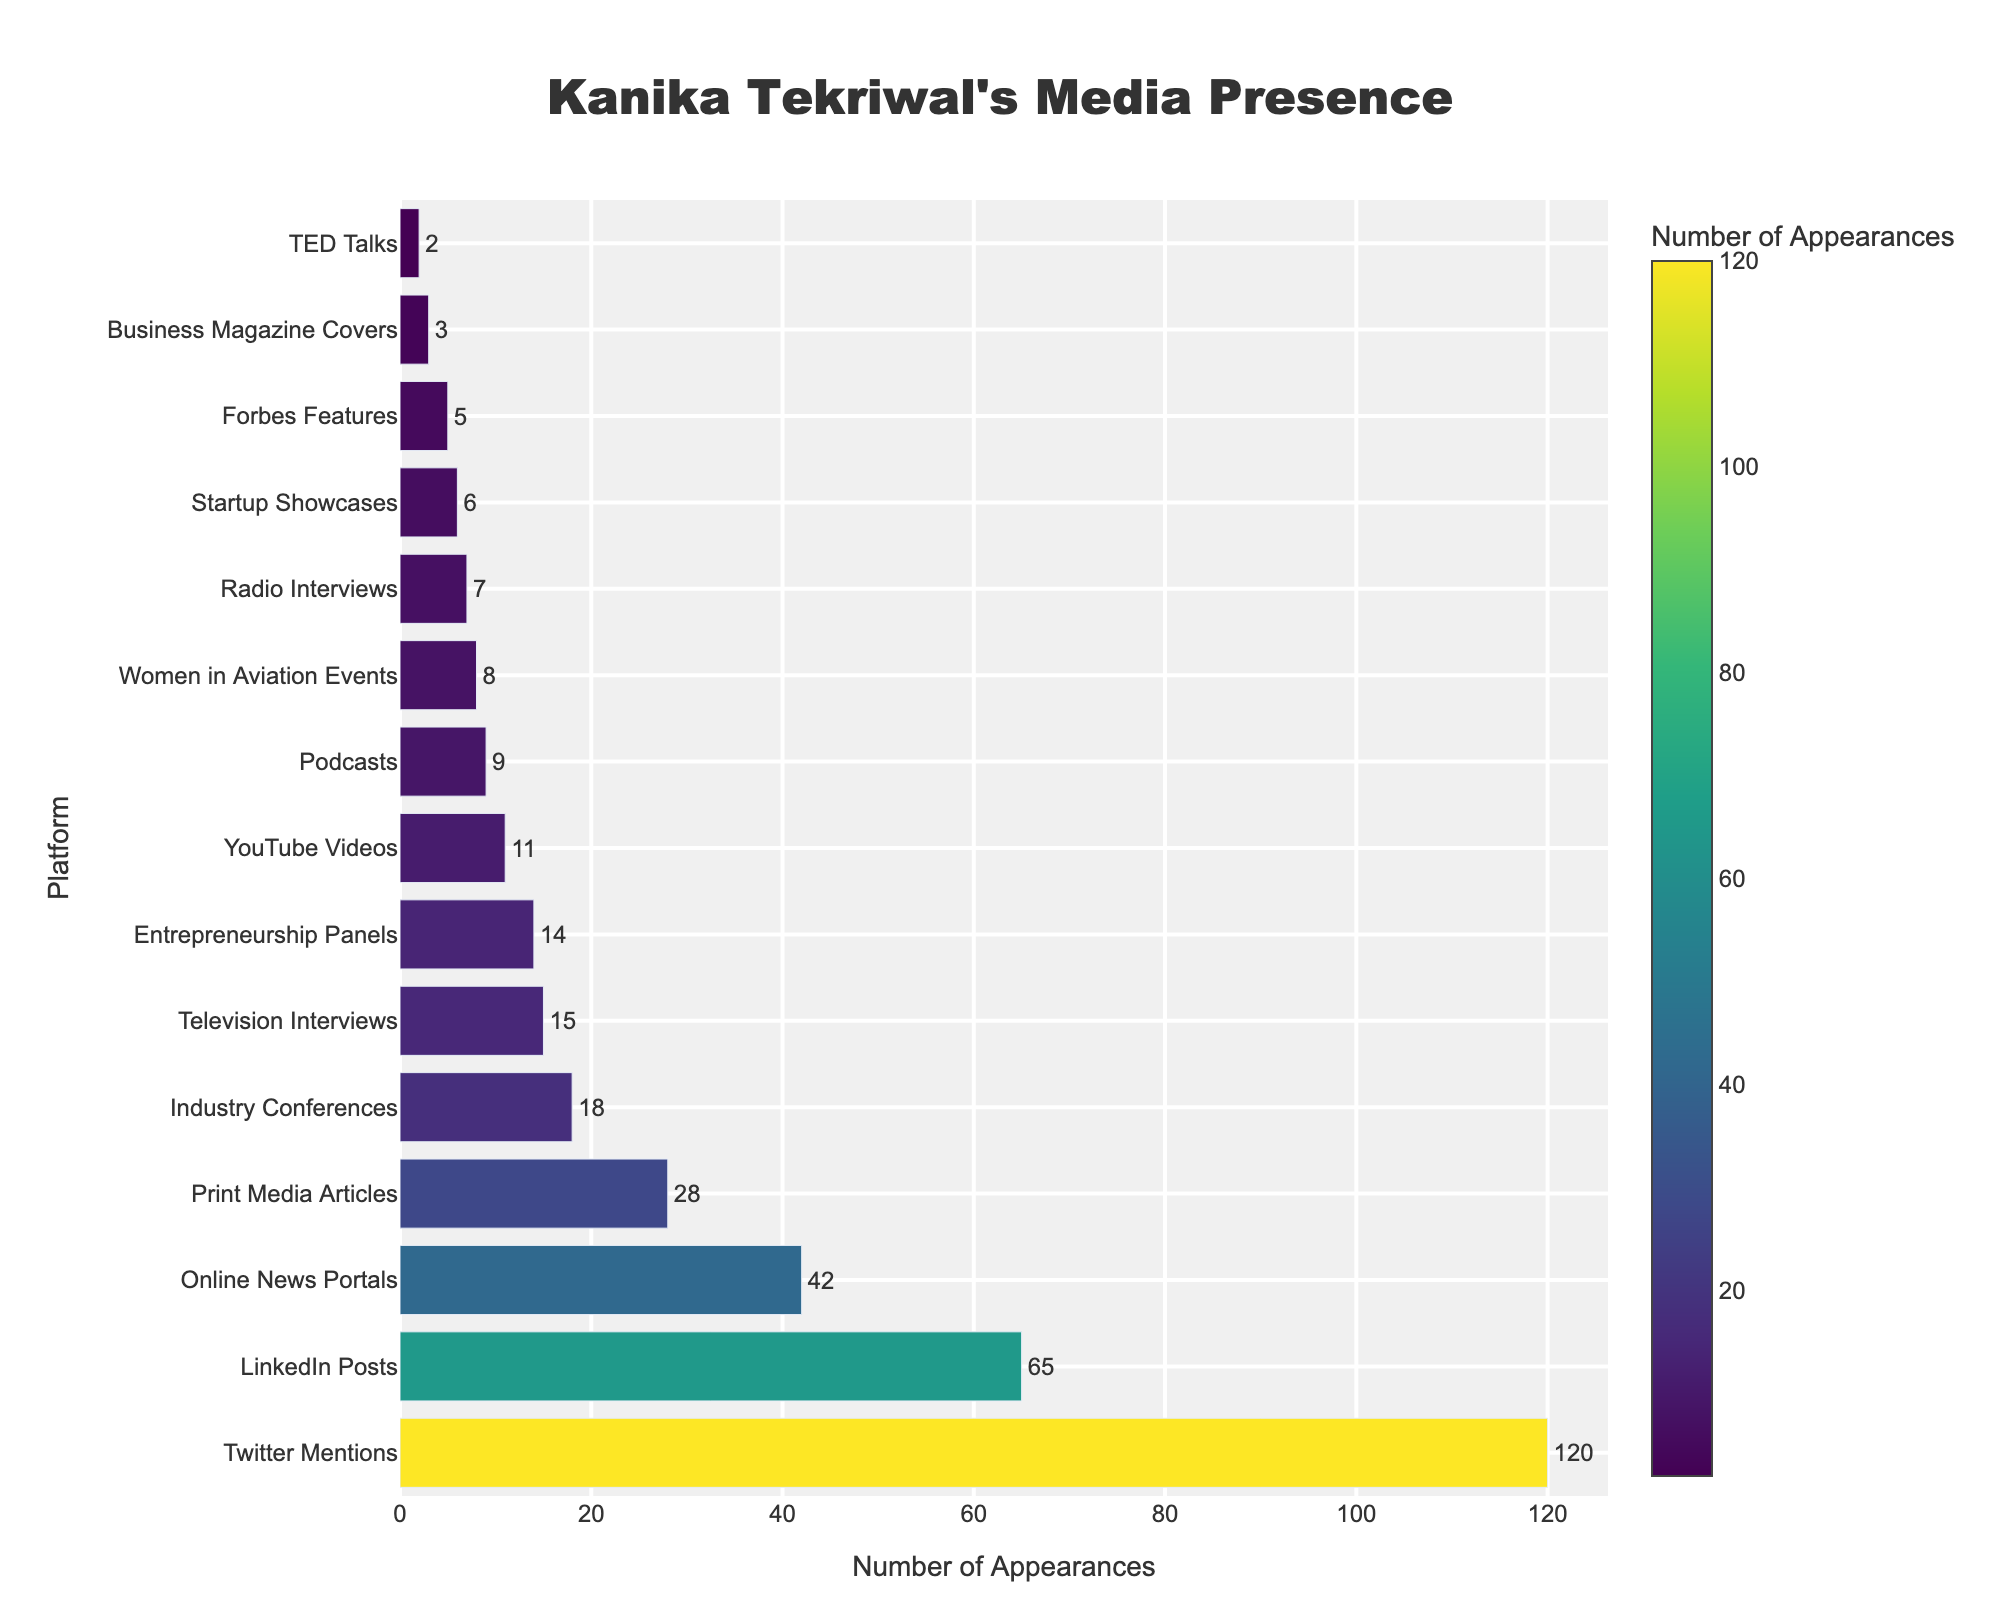Which platform has the highest number of appearances? The bar chart shows the number of appearances on each platform; we can identify the platform with the highest bar.
Answer: Twitter Mentions Which platform has fewer appearances: TED Talks or Forbes Features? By comparing the heights of the bars corresponding to TED Talks and Forbes Features, we see that TED Talks has 2 appearances while Forbes Features has 5.
Answer: TED Talks What is the total number of appearances for the top three platforms? The top three platforms by the number of appearances are Twitter Mentions (120), LinkedIn Posts (65), and Online News Portals (42). Summing these gives 120 + 65 + 42 = 227.
Answer: 227 How many more appearances does Print Media Articles have compared to Radio Interviews? From the figure, Print Media Articles has 28 appearances, and Radio Interviews has 7. The difference is 28 - 7 = 21.
Answer: 21 What is the average number of appearances across all platforms? The total number of appearances across all platforms is the sum of all the individual appearances: 15 + 28 + 42 + 9 + 65 + 120 + 18 + 2 + 11 + 7 + 5 + 3 + 14 + 8 + 6 = 353. There are 15 platforms, so the average is 353 / 15 ≈ 23.53.
Answer: 23.53 Which has more appearances: Industry Conferences or Entrepreneurship Panels? Industry Conferences have 18 appearances, and Entrepreneurship Panels have 14. Comparing these, Industry Conferences has more appearances.
Answer: Industry Conferences What is the median number of appearances for the platforms? The sorted list of appearances is [2, 3, 5, 6, 7, 8, 9, 11, 14, 15, 18, 28, 42, 65, 120]. The median is the middle value, which is the eighth value when the data is ordered, so the median is 11.
Answer: 11 How many platforms have fewer than 10 appearances? Platforms with fewer than 10 appearances are TED Talks (2), Business Magazine Covers (3), Forbes Features (5), Startup Showcases (6), Radio Interviews (7), Women in Aviation Events (8), and Podcasts (9), making a total of 7 platforms.
Answer: 7 